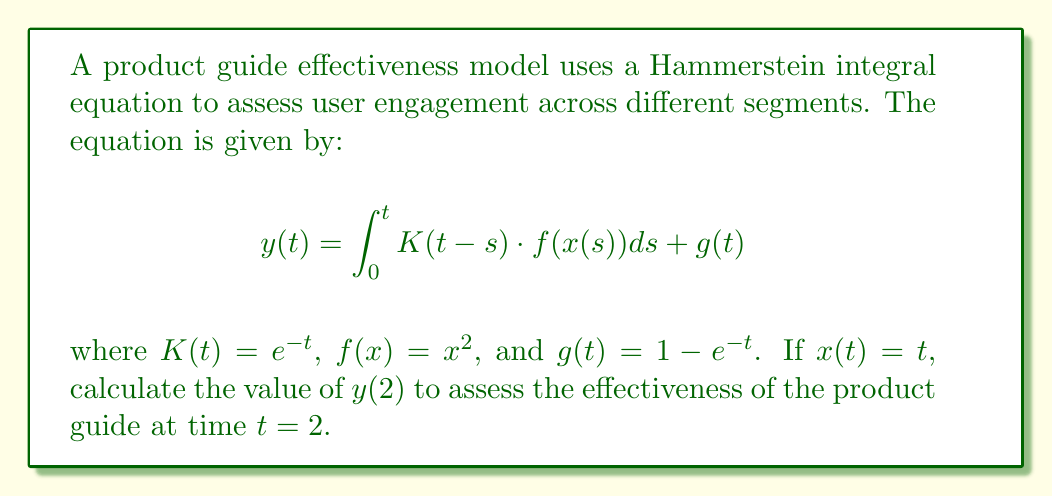Could you help me with this problem? To solve this problem, we'll follow these steps:

1) First, let's substitute the given functions into the Hammerstein integral equation:

   $$y(2) = \int_0^2 e^{-(2-s)} \cdot s^2 ds + (1 - e^{-2})$$

2) Let's focus on solving the integral part:

   $$\int_0^2 e^{-(2-s)} \cdot s^2 ds = e^{-2} \int_0^2 e^s \cdot s^2 ds$$

3) We can solve this using integration by parts twice. Let $u = s^2$ and $dv = e^s ds$:

   $$e^{-2} \left[s^2e^s - 2se^s + 2e^s\right]_0^2$$

4) Evaluating the bounds:

   $$e^{-2} \left[(4e^2 - 4e^2 + 2e^2) - (0 - 0 + 2)\right]$$
   $$= e^{-2} \left[2e^2 - 2\right]$$
   $$= 2 - 2e^{-2}$$

5) Now, let's add this result to the $g(t)$ term:

   $$y(2) = (2 - 2e^{-2}) + (1 - e^{-2})$$
   $$= 3 - 3e^{-2}$$

This final value represents the effectiveness of the product guide at time $t=2$ across different user segments.
Answer: $3 - 3e^{-2}$ 